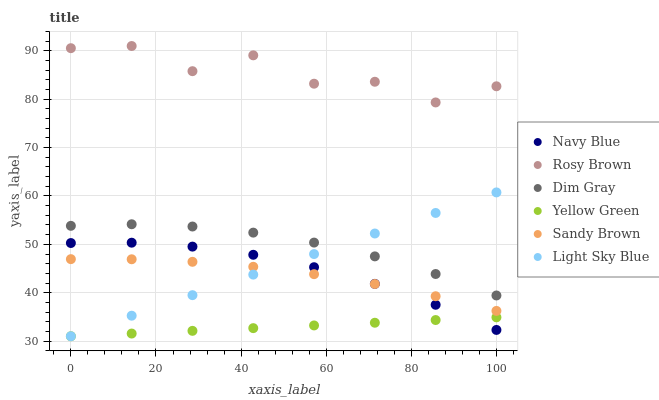Does Yellow Green have the minimum area under the curve?
Answer yes or no. Yes. Does Rosy Brown have the maximum area under the curve?
Answer yes or no. Yes. Does Navy Blue have the minimum area under the curve?
Answer yes or no. No. Does Navy Blue have the maximum area under the curve?
Answer yes or no. No. Is Light Sky Blue the smoothest?
Answer yes or no. Yes. Is Rosy Brown the roughest?
Answer yes or no. Yes. Is Yellow Green the smoothest?
Answer yes or no. No. Is Yellow Green the roughest?
Answer yes or no. No. Does Yellow Green have the lowest value?
Answer yes or no. Yes. Does Navy Blue have the lowest value?
Answer yes or no. No. Does Rosy Brown have the highest value?
Answer yes or no. Yes. Does Navy Blue have the highest value?
Answer yes or no. No. Is Yellow Green less than Rosy Brown?
Answer yes or no. Yes. Is Rosy Brown greater than Light Sky Blue?
Answer yes or no. Yes. Does Light Sky Blue intersect Sandy Brown?
Answer yes or no. Yes. Is Light Sky Blue less than Sandy Brown?
Answer yes or no. No. Is Light Sky Blue greater than Sandy Brown?
Answer yes or no. No. Does Yellow Green intersect Rosy Brown?
Answer yes or no. No. 